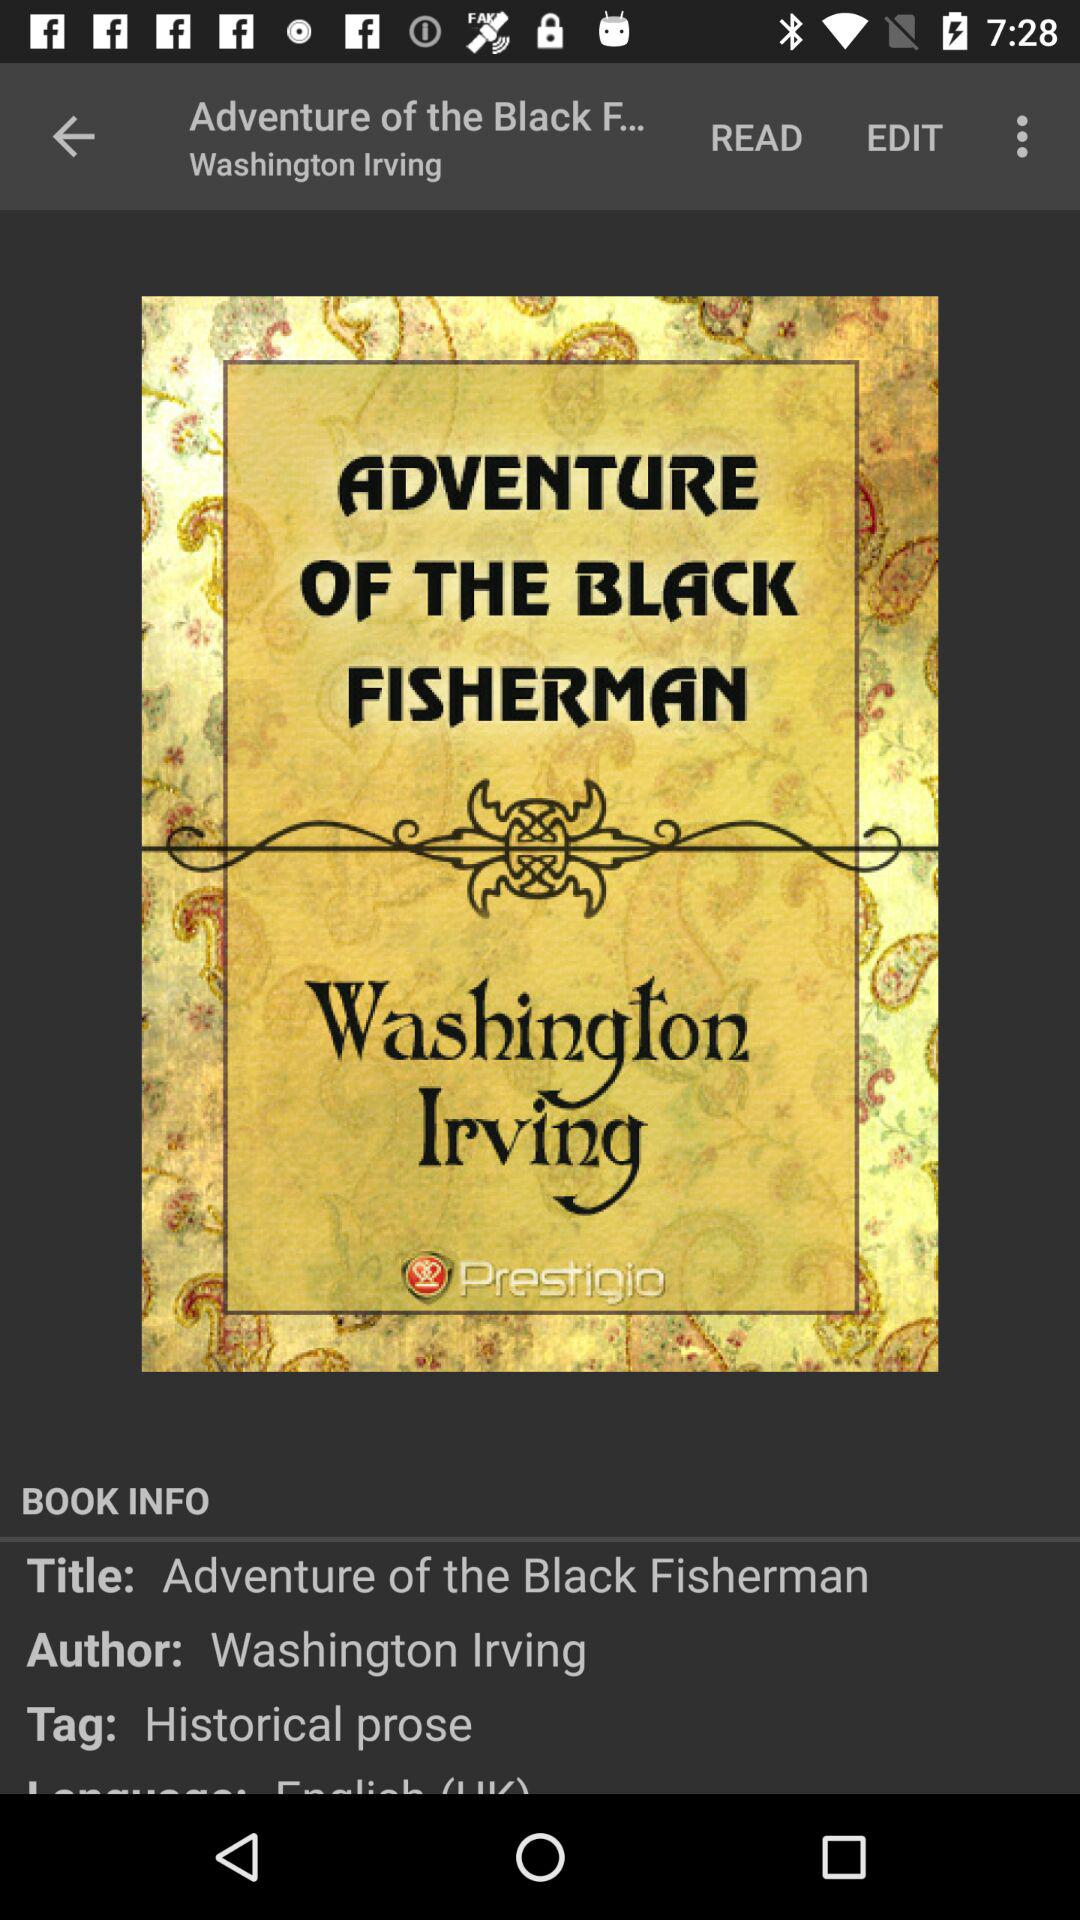What's the title of the book? The title of the book is "Adventure of the Black Fisherman". 